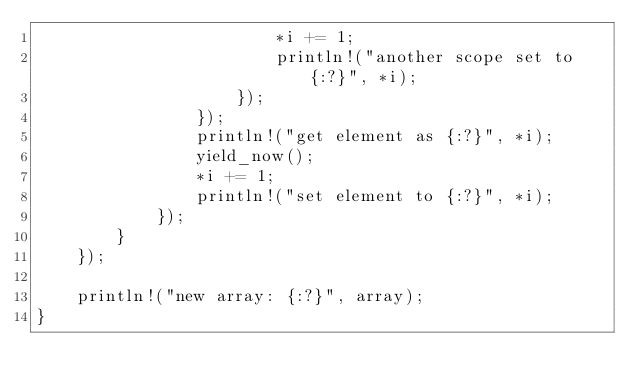Convert code to text. <code><loc_0><loc_0><loc_500><loc_500><_Rust_>                        *i += 1;
                        println!("another scope set to {:?}", *i);
                    });
                });
                println!("get element as {:?}", *i);
                yield_now();
                *i += 1;
                println!("set element to {:?}", *i);
            });
        }
    });

    println!("new array: {:?}", array);
}
</code> 